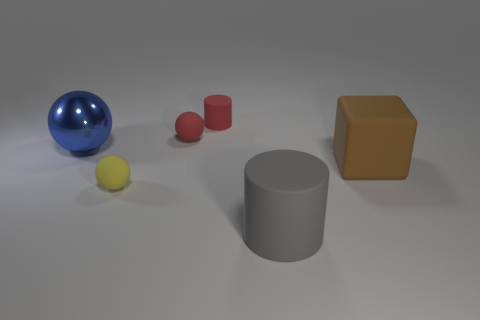How many rubber objects are to the right of the yellow matte object in front of the large brown object?
Your answer should be very brief. 4. What color is the cylinder in front of the matte sphere behind the big sphere?
Give a very brief answer. Gray. What is the material of the sphere that is both to the right of the large metal sphere and behind the brown block?
Provide a short and direct response. Rubber. Are there any other metal objects that have the same shape as the yellow object?
Give a very brief answer. Yes. Do the tiny object in front of the large matte block and the big brown rubber thing have the same shape?
Provide a succinct answer. No. How many objects are both in front of the large brown rubber thing and left of the red matte sphere?
Your answer should be very brief. 1. What is the shape of the tiny matte object in front of the big brown block?
Offer a very short reply. Sphere. How many yellow things are the same material as the gray thing?
Your response must be concise. 1. There is a large blue thing; is its shape the same as the large rubber object that is in front of the large brown object?
Make the answer very short. No. Is there a large rubber thing to the left of the small red matte object behind the matte ball that is on the right side of the tiny yellow thing?
Your answer should be compact. No. 